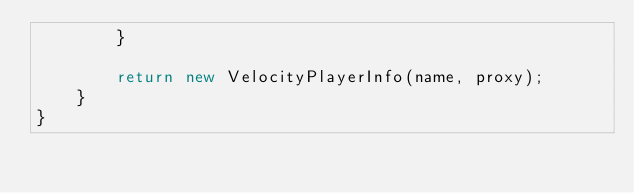<code> <loc_0><loc_0><loc_500><loc_500><_Java_>        }

        return new VelocityPlayerInfo(name, proxy);
    }
}
</code> 